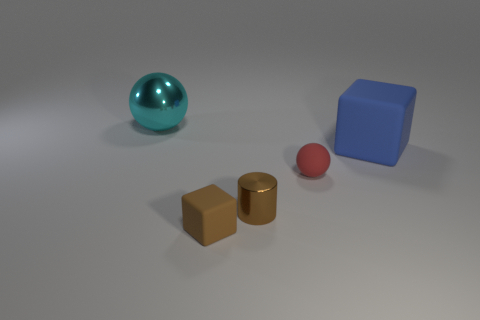Add 3 matte things. How many objects exist? 8 Subtract all balls. How many objects are left? 3 Add 2 metal cylinders. How many metal cylinders exist? 3 Subtract 0 red blocks. How many objects are left? 5 Subtract all tiny green rubber objects. Subtract all small brown metallic things. How many objects are left? 4 Add 3 tiny brown matte objects. How many tiny brown matte objects are left? 4 